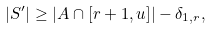<formula> <loc_0><loc_0><loc_500><loc_500>| S ^ { \prime } | \geq | A \cap [ r + 1 , u ] | - \delta _ { 1 , r } ,</formula> 